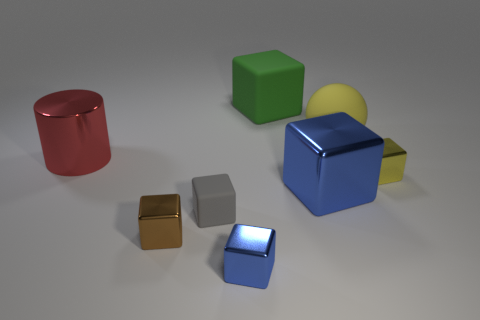What number of objects are either big metal things that are on the right side of the small blue metallic thing or small metallic blocks that are to the right of the yellow ball?
Keep it short and to the point. 2. There is a rubber cube in front of the metallic cylinder; does it have the same size as the shiny block that is left of the tiny blue cube?
Make the answer very short. Yes. What color is the big shiny object that is the same shape as the tiny gray matte thing?
Your response must be concise. Blue. Is there anything else that has the same shape as the large yellow rubber thing?
Offer a very short reply. No. Is the number of large yellow matte objects that are right of the brown metal cube greater than the number of large rubber spheres on the right side of the large yellow thing?
Provide a short and direct response. Yes. There is a blue metallic block to the left of the blue cube that is behind the matte cube that is in front of the tiny yellow cube; what size is it?
Offer a terse response. Small. Does the small gray thing have the same material as the large ball that is right of the tiny matte thing?
Ensure brevity in your answer.  Yes. Is the shape of the tiny gray thing the same as the big yellow thing?
Give a very brief answer. No. What number of other things are made of the same material as the yellow cube?
Your answer should be compact. 4. What number of large objects have the same shape as the small brown shiny object?
Ensure brevity in your answer.  2. 